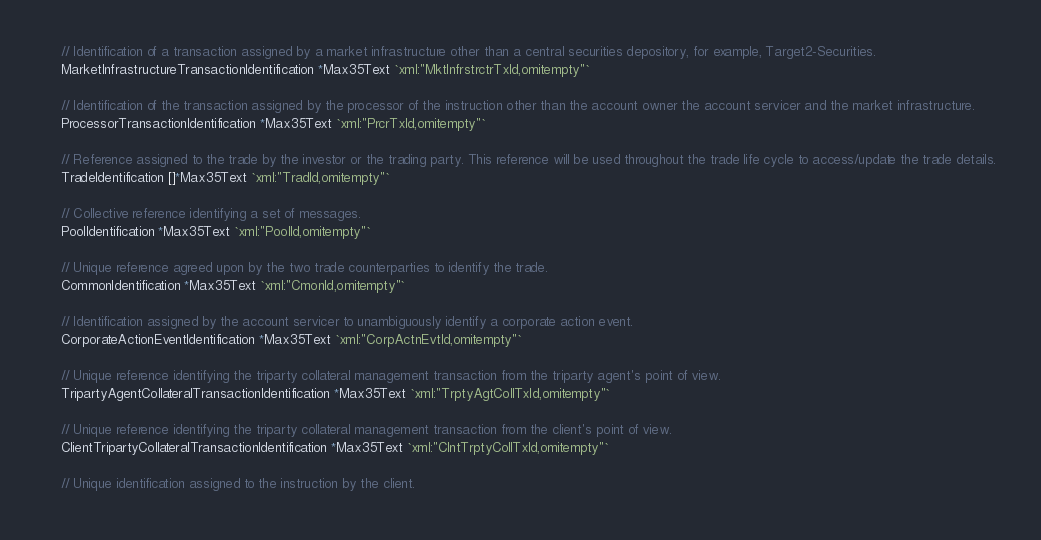Convert code to text. <code><loc_0><loc_0><loc_500><loc_500><_Go_>	// Identification of a transaction assigned by a market infrastructure other than a central securities depository, for example, Target2-Securities.
	MarketInfrastructureTransactionIdentification *Max35Text `xml:"MktInfrstrctrTxId,omitempty"`

	// Identification of the transaction assigned by the processor of the instruction other than the account owner the account servicer and the market infrastructure.
	ProcessorTransactionIdentification *Max35Text `xml:"PrcrTxId,omitempty"`

	// Reference assigned to the trade by the investor or the trading party. This reference will be used throughout the trade life cycle to access/update the trade details.
	TradeIdentification []*Max35Text `xml:"TradId,omitempty"`

	// Collective reference identifying a set of messages.
	PoolIdentification *Max35Text `xml:"PoolId,omitempty"`

	// Unique reference agreed upon by the two trade counterparties to identify the trade.
	CommonIdentification *Max35Text `xml:"CmonId,omitempty"`

	// Identification assigned by the account servicer to unambiguously identify a corporate action event.
	CorporateActionEventIdentification *Max35Text `xml:"CorpActnEvtId,omitempty"`

	// Unique reference identifying the triparty collateral management transaction from the triparty agent's point of view.
	TripartyAgentCollateralTransactionIdentification *Max35Text `xml:"TrptyAgtCollTxId,omitempty"`

	// Unique reference identifying the triparty collateral management transaction from the client's point of view.
	ClientTripartyCollateralTransactionIdentification *Max35Text `xml:"ClntTrptyCollTxId,omitempty"`

	// Unique identification assigned to the instruction by the client.</code> 